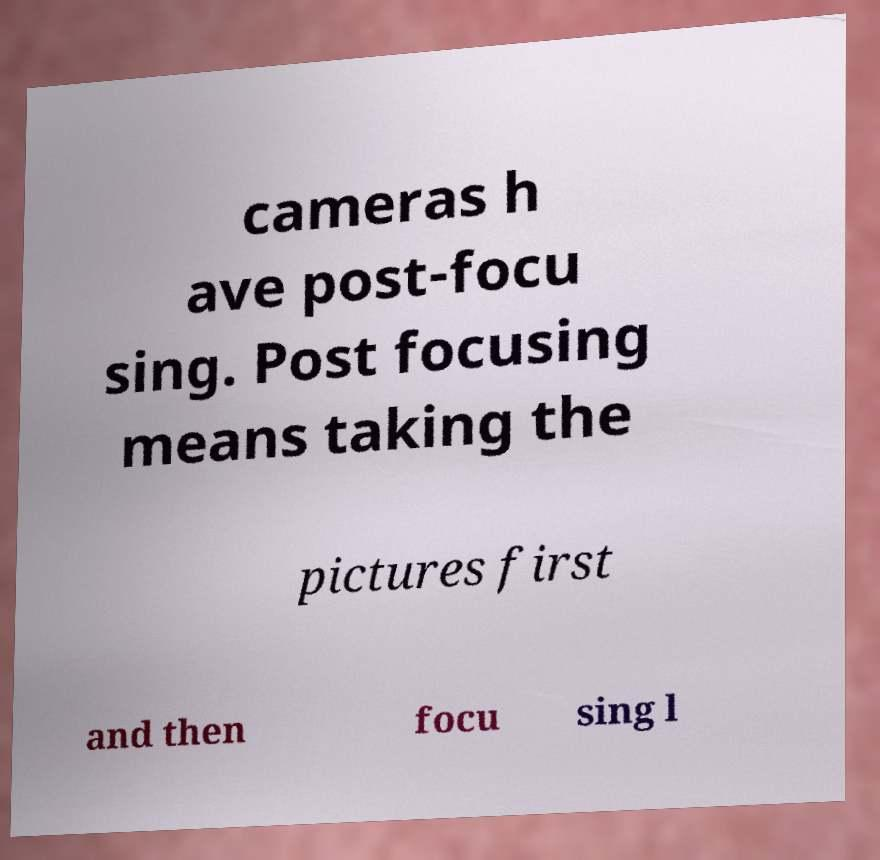Please read and relay the text visible in this image. What does it say? cameras h ave post-focu sing. Post focusing means taking the pictures first and then focu sing l 